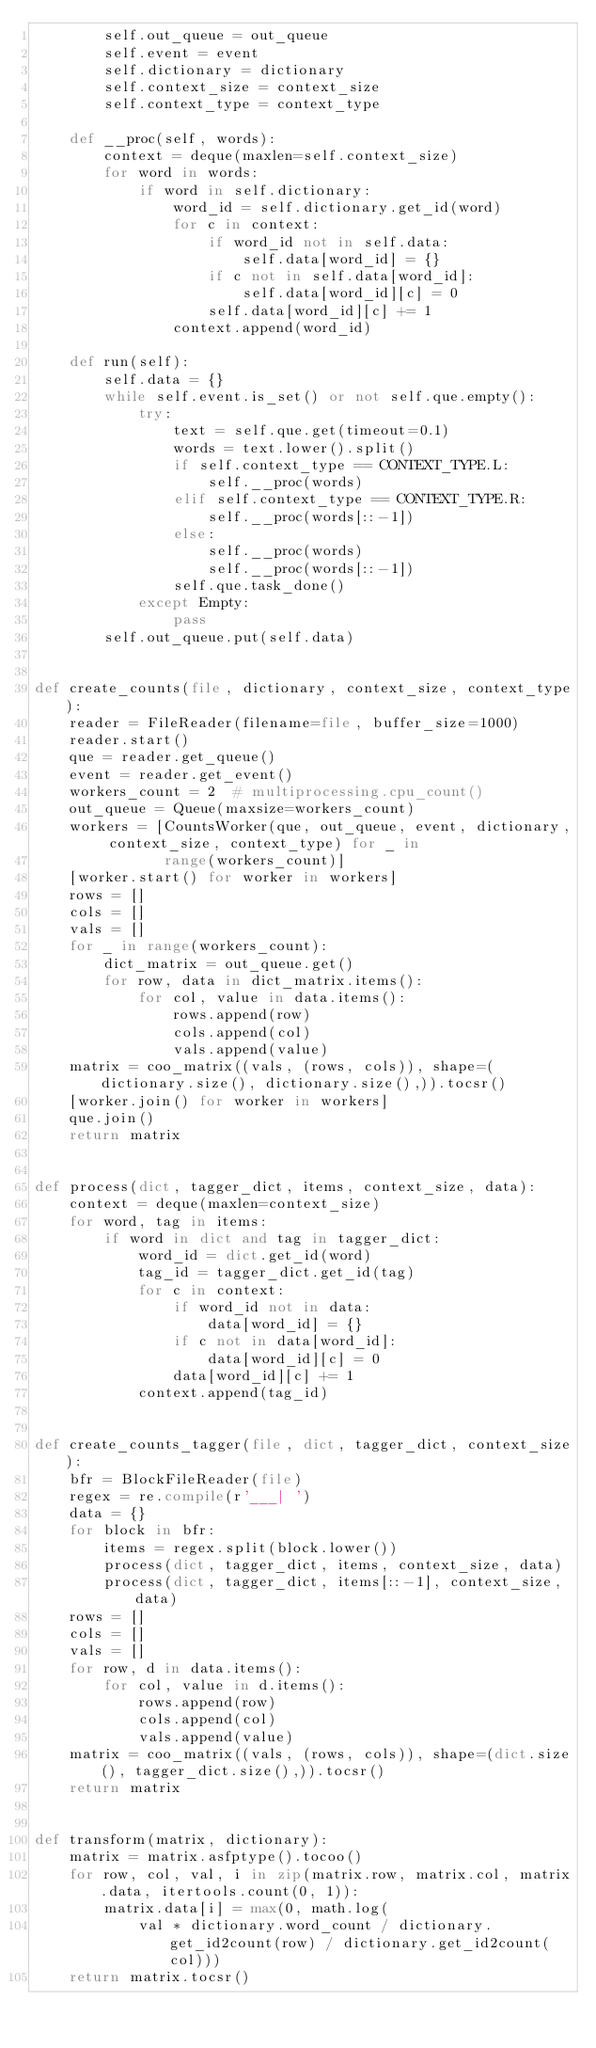<code> <loc_0><loc_0><loc_500><loc_500><_Python_>        self.out_queue = out_queue
        self.event = event
        self.dictionary = dictionary
        self.context_size = context_size
        self.context_type = context_type

    def __proc(self, words):
        context = deque(maxlen=self.context_size)
        for word in words:
            if word in self.dictionary:
                word_id = self.dictionary.get_id(word)
                for c in context:
                    if word_id not in self.data:
                        self.data[word_id] = {}
                    if c not in self.data[word_id]:
                        self.data[word_id][c] = 0
                    self.data[word_id][c] += 1
                context.append(word_id)

    def run(self):
        self.data = {}
        while self.event.is_set() or not self.que.empty():
            try:
                text = self.que.get(timeout=0.1)
                words = text.lower().split()
                if self.context_type == CONTEXT_TYPE.L:
                    self.__proc(words)
                elif self.context_type == CONTEXT_TYPE.R:
                    self.__proc(words[::-1])
                else:
                    self.__proc(words)
                    self.__proc(words[::-1])
                self.que.task_done()
            except Empty:
                pass
        self.out_queue.put(self.data)


def create_counts(file, dictionary, context_size, context_type):
    reader = FileReader(filename=file, buffer_size=1000)
    reader.start()
    que = reader.get_queue()
    event = reader.get_event()
    workers_count = 2  # multiprocessing.cpu_count()
    out_queue = Queue(maxsize=workers_count)
    workers = [CountsWorker(que, out_queue, event, dictionary, context_size, context_type) for _ in
               range(workers_count)]
    [worker.start() for worker in workers]
    rows = []
    cols = []
    vals = []
    for _ in range(workers_count):
        dict_matrix = out_queue.get()
        for row, data in dict_matrix.items():
            for col, value in data.items():
                rows.append(row)
                cols.append(col)
                vals.append(value)
    matrix = coo_matrix((vals, (rows, cols)), shape=(dictionary.size(), dictionary.size(),)).tocsr()
    [worker.join() for worker in workers]
    que.join()
    return matrix


def process(dict, tagger_dict, items, context_size, data):
    context = deque(maxlen=context_size)
    for word, tag in items:
        if word in dict and tag in tagger_dict:
            word_id = dict.get_id(word)
            tag_id = tagger_dict.get_id(tag)
            for c in context:
                if word_id not in data:
                    data[word_id] = {}
                if c not in data[word_id]:
                    data[word_id][c] = 0
                data[word_id][c] += 1
            context.append(tag_id)


def create_counts_tagger(file, dict, tagger_dict, context_size):
    bfr = BlockFileReader(file)
    regex = re.compile(r'___| ')
    data = {}
    for block in bfr:
        items = regex.split(block.lower())
        process(dict, tagger_dict, items, context_size, data)
        process(dict, tagger_dict, items[::-1], context_size, data)
    rows = []
    cols = []
    vals = []
    for row, d in data.items():
        for col, value in d.items():
            rows.append(row)
            cols.append(col)
            vals.append(value)
    matrix = coo_matrix((vals, (rows, cols)), shape=(dict.size(), tagger_dict.size(),)).tocsr()
    return matrix


def transform(matrix, dictionary):
    matrix = matrix.asfptype().tocoo()
    for row, col, val, i in zip(matrix.row, matrix.col, matrix.data, itertools.count(0, 1)):
        matrix.data[i] = max(0, math.log(
            val * dictionary.word_count / dictionary.get_id2count(row) / dictionary.get_id2count(col)))
    return matrix.tocsr()
</code> 